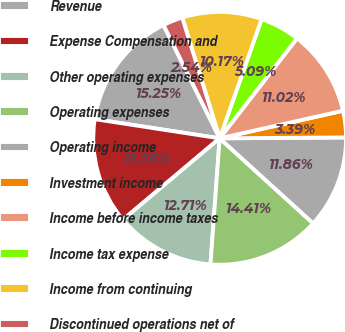<chart> <loc_0><loc_0><loc_500><loc_500><pie_chart><fcel>Revenue<fcel>Expense Compensation and<fcel>Other operating expenses<fcel>Operating expenses<fcel>Operating income<fcel>Investment income<fcel>Income before income taxes<fcel>Income tax expense<fcel>Income from continuing<fcel>Discontinued operations net of<nl><fcel>15.25%<fcel>13.56%<fcel>12.71%<fcel>14.41%<fcel>11.86%<fcel>3.39%<fcel>11.02%<fcel>5.09%<fcel>10.17%<fcel>2.54%<nl></chart> 